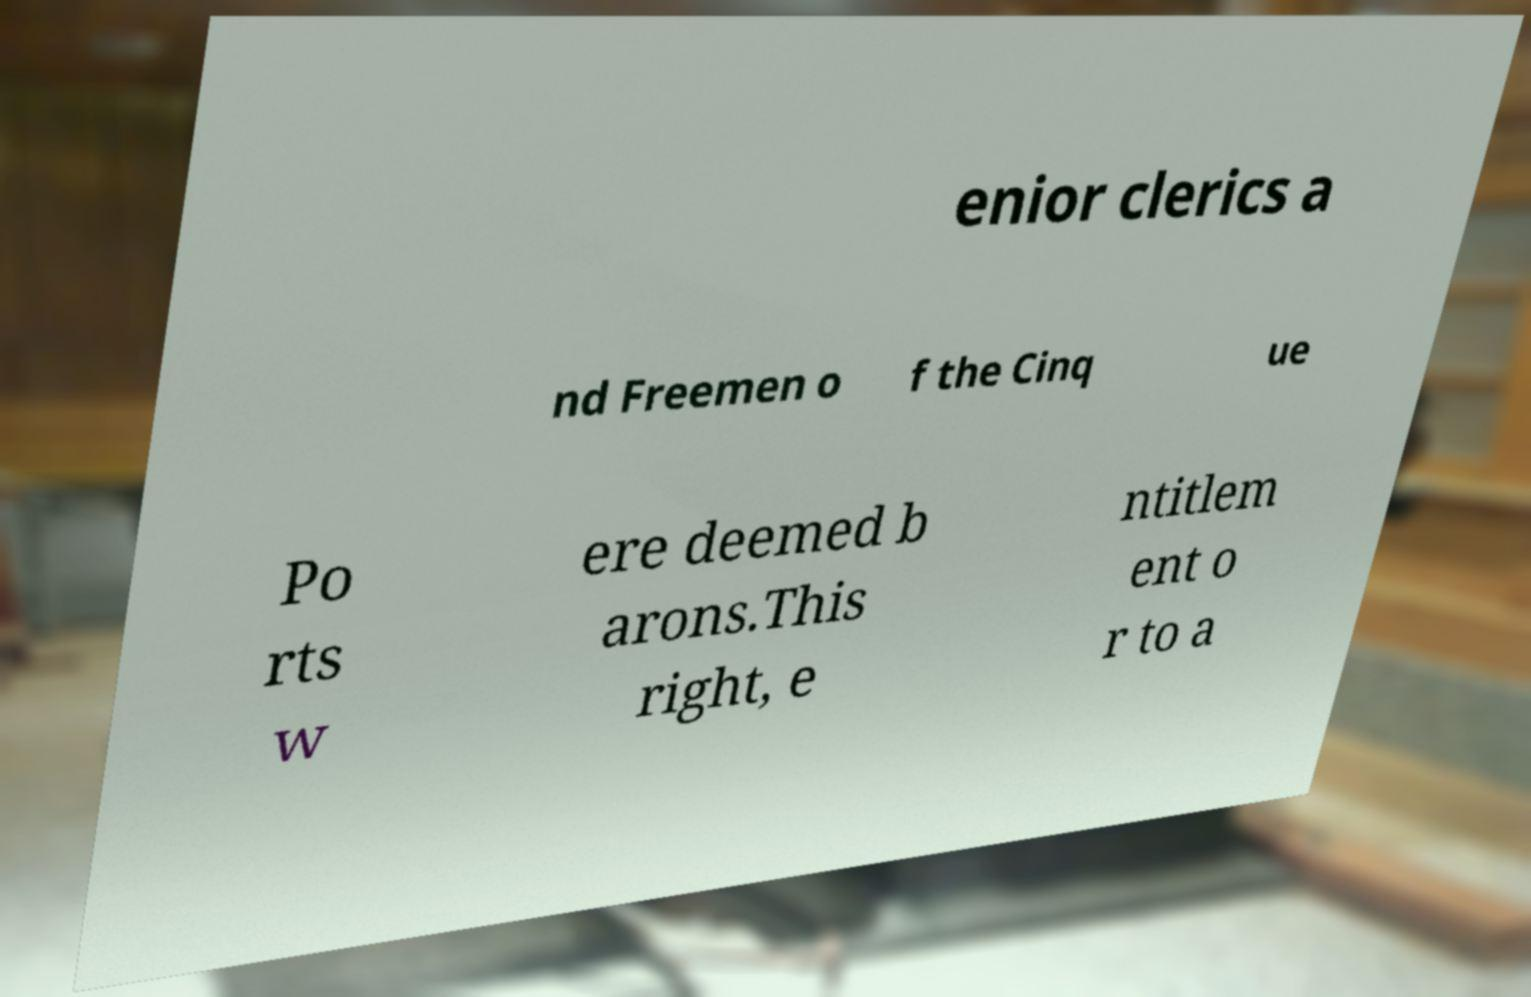Could you extract and type out the text from this image? enior clerics a nd Freemen o f the Cinq ue Po rts w ere deemed b arons.This right, e ntitlem ent o r to a 